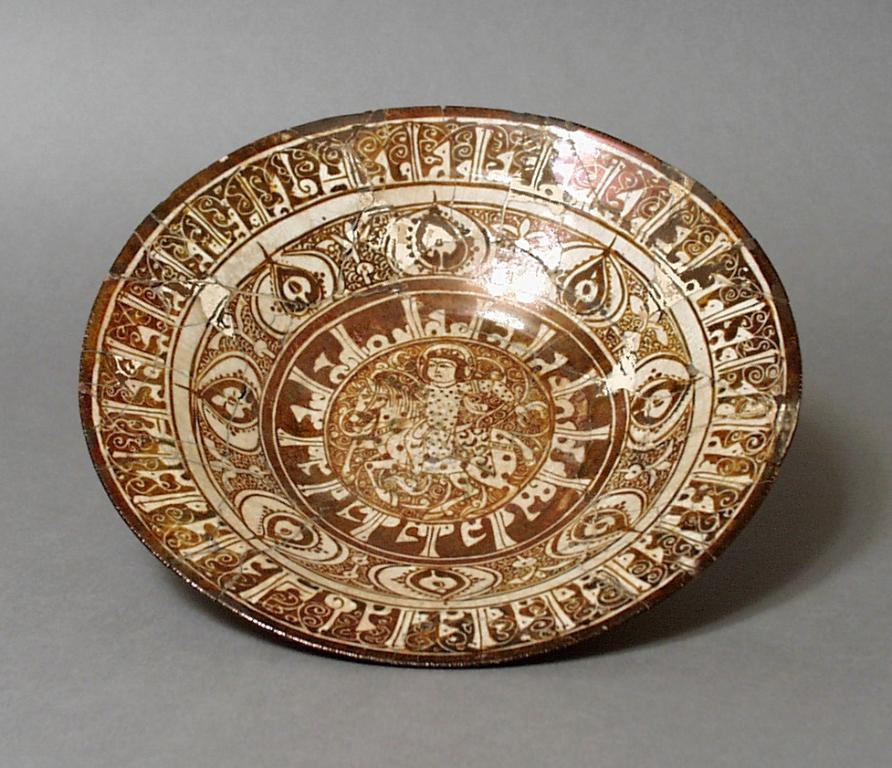Can you describe this image briefly? In this picture it looks like a plate and I can see plain background. 